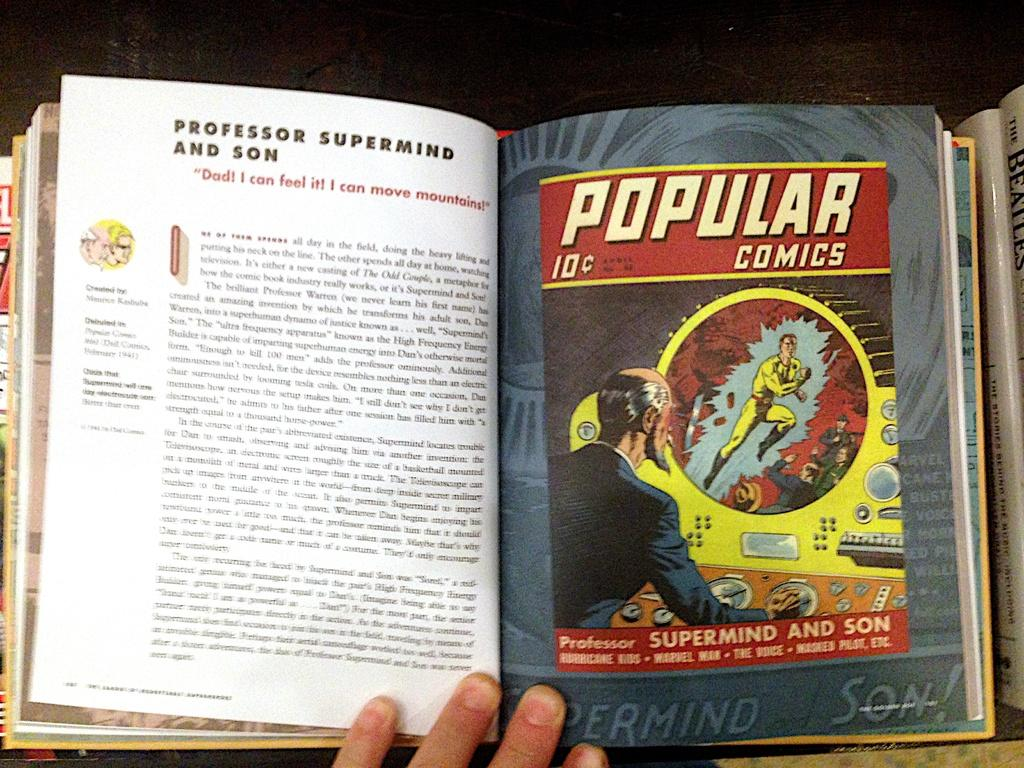Provide a one-sentence caption for the provided image. Someone is reading a book with popular comics. 